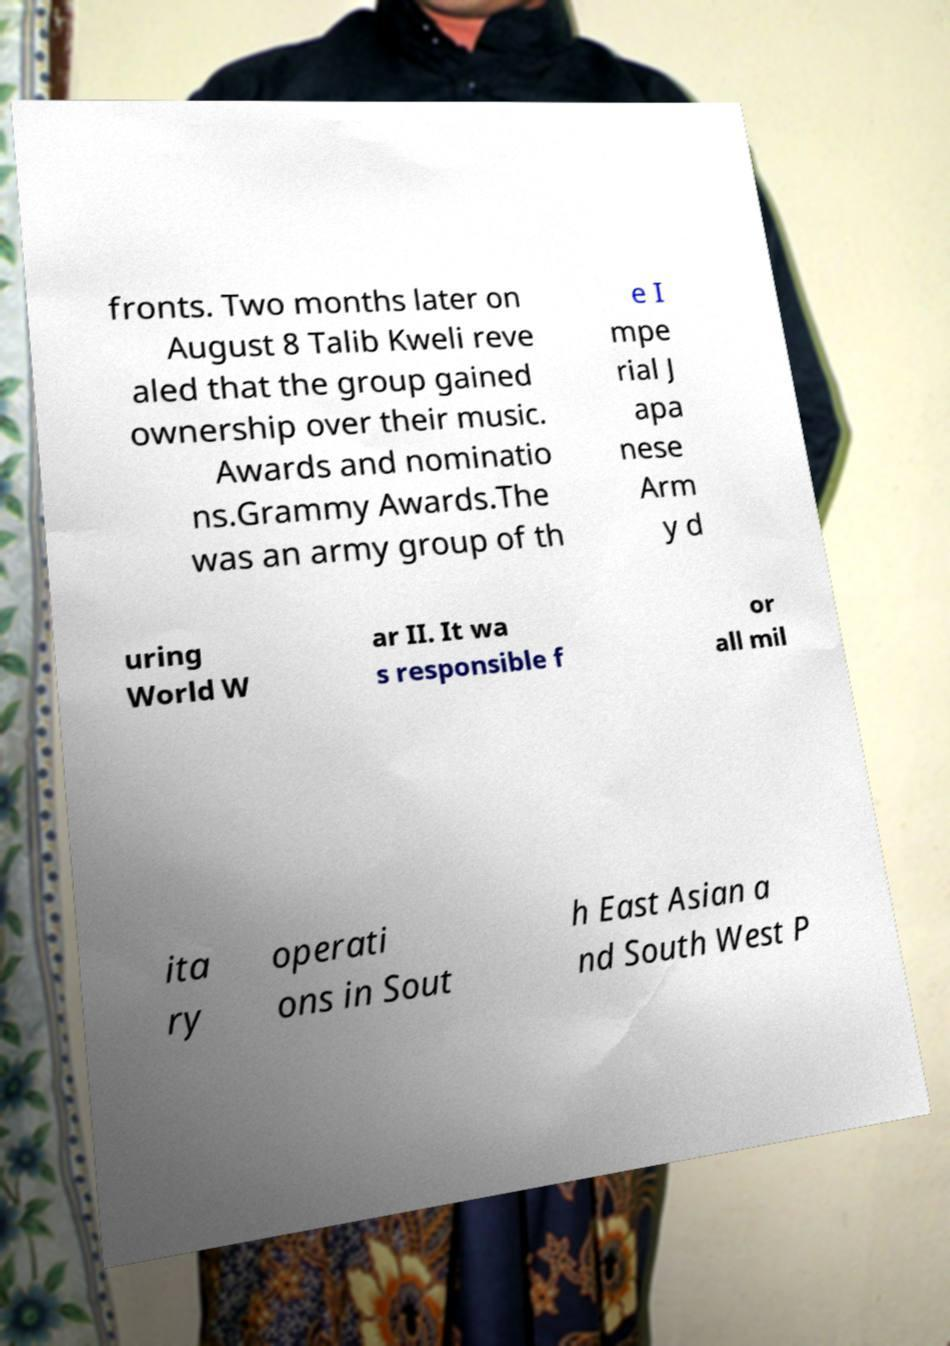Can you read and provide the text displayed in the image?This photo seems to have some interesting text. Can you extract and type it out for me? fronts. Two months later on August 8 Talib Kweli reve aled that the group gained ownership over their music. Awards and nominatio ns.Grammy Awards.The was an army group of th e I mpe rial J apa nese Arm y d uring World W ar II. It wa s responsible f or all mil ita ry operati ons in Sout h East Asian a nd South West P 